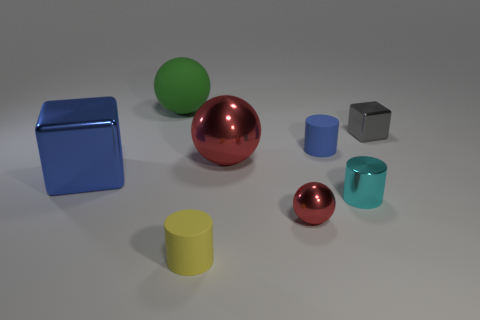What number of other objects are there of the same material as the tiny yellow object?
Your answer should be compact. 2. Do the blue cube and the cyan cylinder have the same material?
Your answer should be very brief. Yes. There is a rubber thing to the right of the small red shiny object; what size is it?
Your answer should be compact. Small. There is a tiny object that is on the left side of the gray object and behind the big blue cube; what color is it?
Provide a short and direct response. Blue. Do the blue object that is to the right of the yellow matte object and the small yellow rubber object have the same size?
Your answer should be very brief. Yes. Are there any cylinders that are to the left of the red thing that is behind the blue metal block?
Your answer should be compact. Yes. What is the large green object made of?
Offer a terse response. Rubber. Are there any big cubes behind the gray thing?
Provide a succinct answer. No. What is the size of the blue thing that is the same shape as the gray metallic object?
Give a very brief answer. Large. Are there the same number of small red metallic objects behind the large rubber object and gray metal cubes in front of the small metallic block?
Offer a very short reply. Yes. 